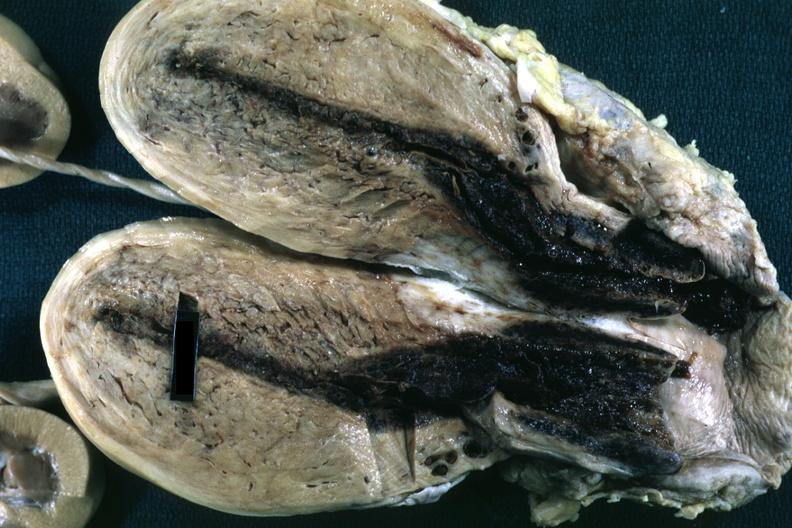s this photo of infant from head to toe present?
Answer the question using a single word or phrase. No 